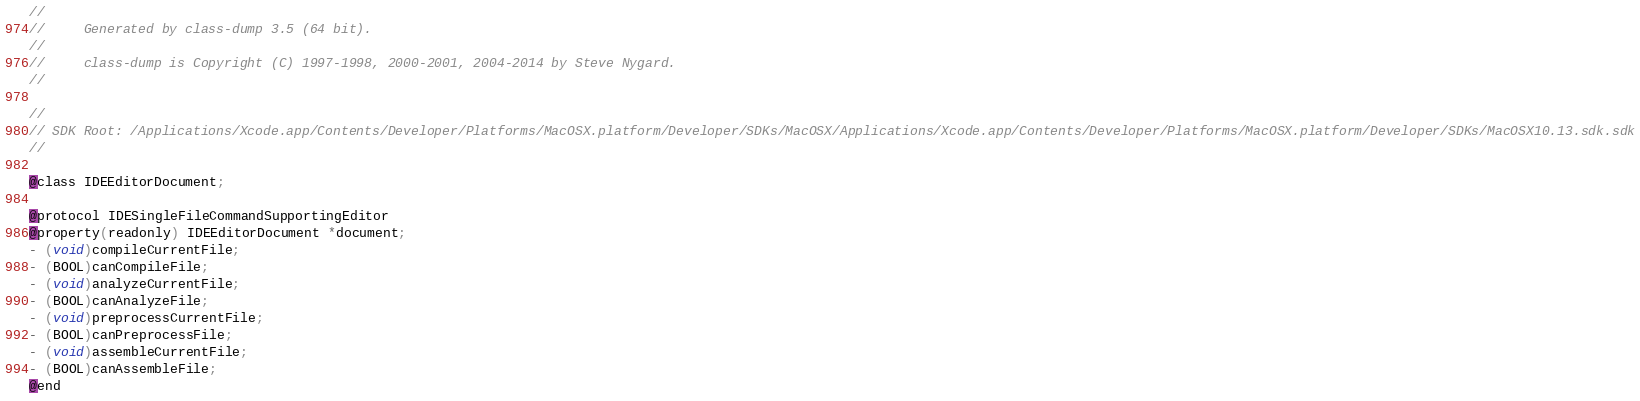Convert code to text. <code><loc_0><loc_0><loc_500><loc_500><_C_>//
//     Generated by class-dump 3.5 (64 bit).
//
//     class-dump is Copyright (C) 1997-1998, 2000-2001, 2004-2014 by Steve Nygard.
//

//
// SDK Root: /Applications/Xcode.app/Contents/Developer/Platforms/MacOSX.platform/Developer/SDKs/MacOSX/Applications/Xcode.app/Contents/Developer/Platforms/MacOSX.platform/Developer/SDKs/MacOSX10.13.sdk.sdk
//

@class IDEEditorDocument;

@protocol IDESingleFileCommandSupportingEditor
@property(readonly) IDEEditorDocument *document;
- (void)compileCurrentFile;
- (BOOL)canCompileFile;
- (void)analyzeCurrentFile;
- (BOOL)canAnalyzeFile;
- (void)preprocessCurrentFile;
- (BOOL)canPreprocessFile;
- (void)assembleCurrentFile;
- (BOOL)canAssembleFile;
@end

</code> 